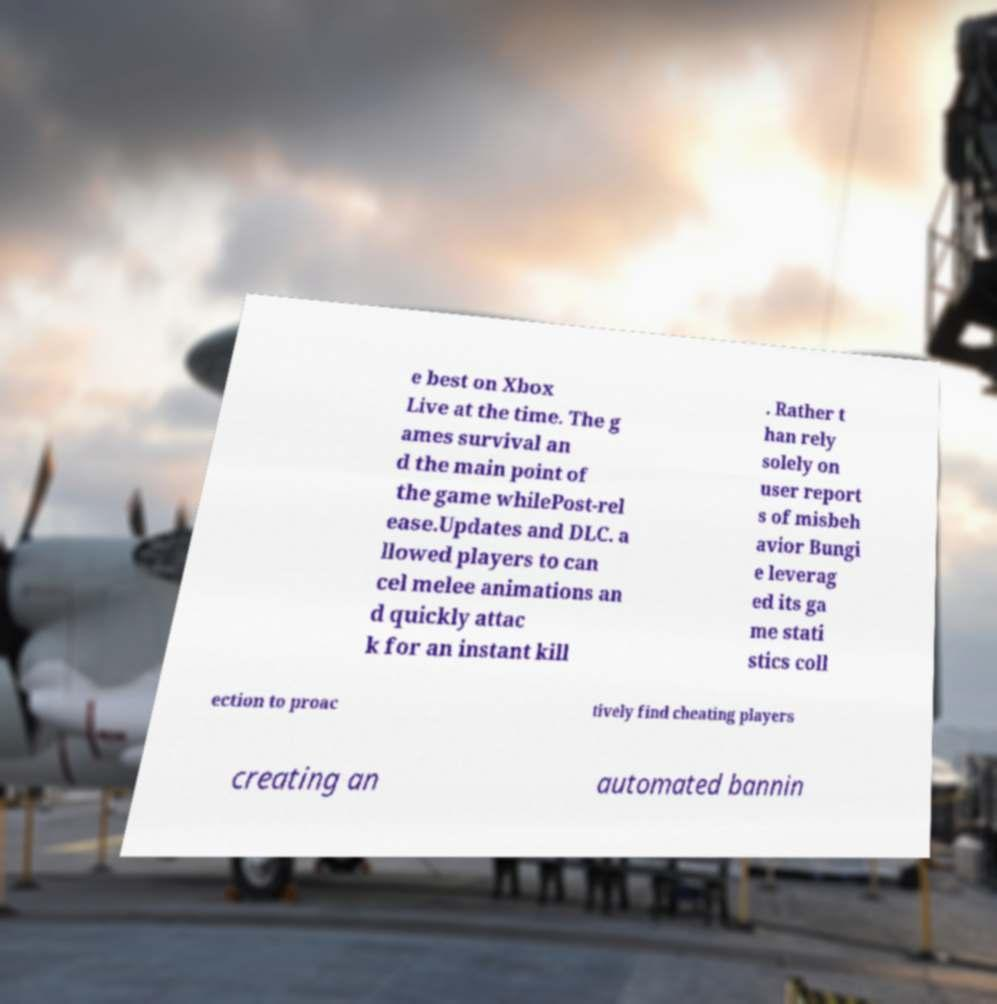Could you extract and type out the text from this image? e best on Xbox Live at the time. The g ames survival an d the main point of the game whilePost-rel ease.Updates and DLC. a llowed players to can cel melee animations an d quickly attac k for an instant kill . Rather t han rely solely on user report s of misbeh avior Bungi e leverag ed its ga me stati stics coll ection to proac tively find cheating players creating an automated bannin 